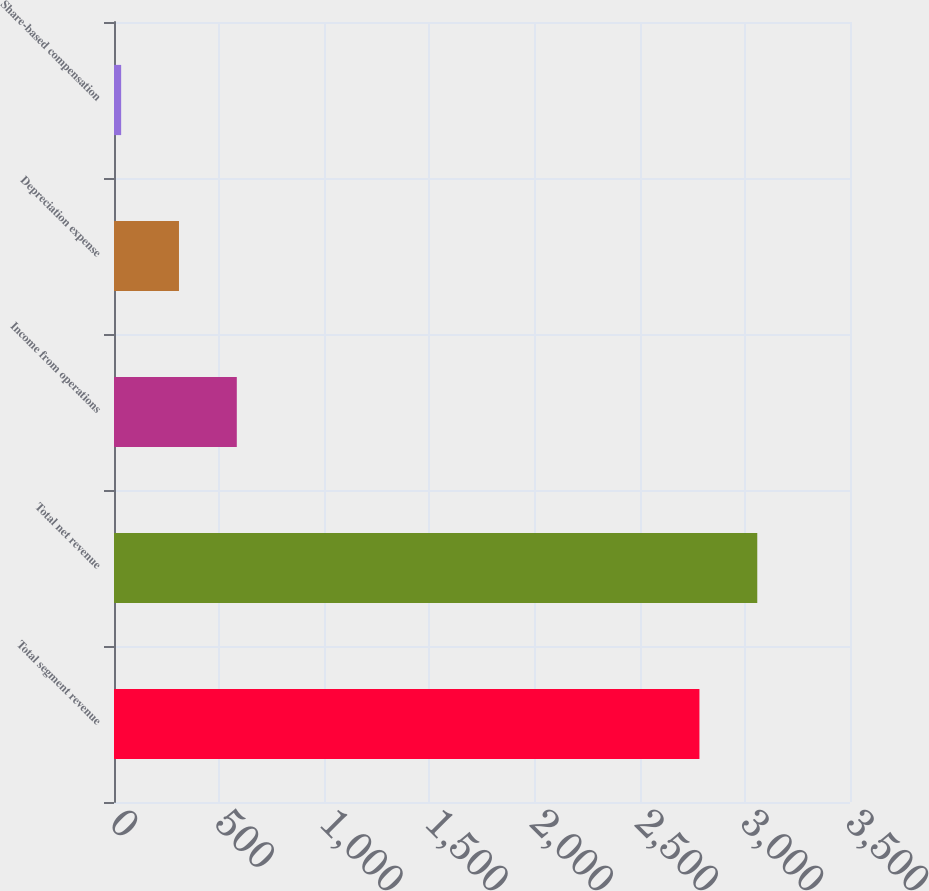Convert chart to OTSL. <chart><loc_0><loc_0><loc_500><loc_500><bar_chart><fcel>Total segment revenue<fcel>Total net revenue<fcel>Income from operations<fcel>Depreciation expense<fcel>Share-based compensation<nl><fcel>2784<fcel>3059<fcel>584<fcel>309<fcel>34<nl></chart> 